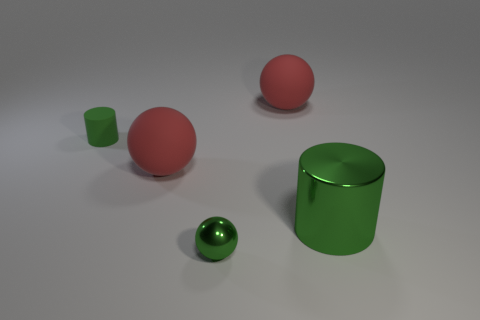Does the tiny green cylinder behind the tiny green metallic sphere have the same material as the large green cylinder?
Give a very brief answer. No. What is the material of the sphere behind the tiny green object behind the red matte object that is on the left side of the small green ball?
Provide a succinct answer. Rubber. What number of metallic objects are either green spheres or large cylinders?
Provide a succinct answer. 2. Are any tiny shiny cylinders visible?
Make the answer very short. No. What is the color of the rubber ball that is on the left side of the big red ball that is behind the tiny green cylinder?
Provide a succinct answer. Red. What number of other things are the same color as the tiny cylinder?
Make the answer very short. 2. What number of things are green metal things or things that are in front of the green rubber cylinder?
Give a very brief answer. 3. There is a small object behind the large green object; what color is it?
Give a very brief answer. Green. What shape is the tiny metallic object?
Offer a very short reply. Sphere. The small green ball that is in front of the large matte object on the right side of the shiny ball is made of what material?
Offer a very short reply. Metal. 